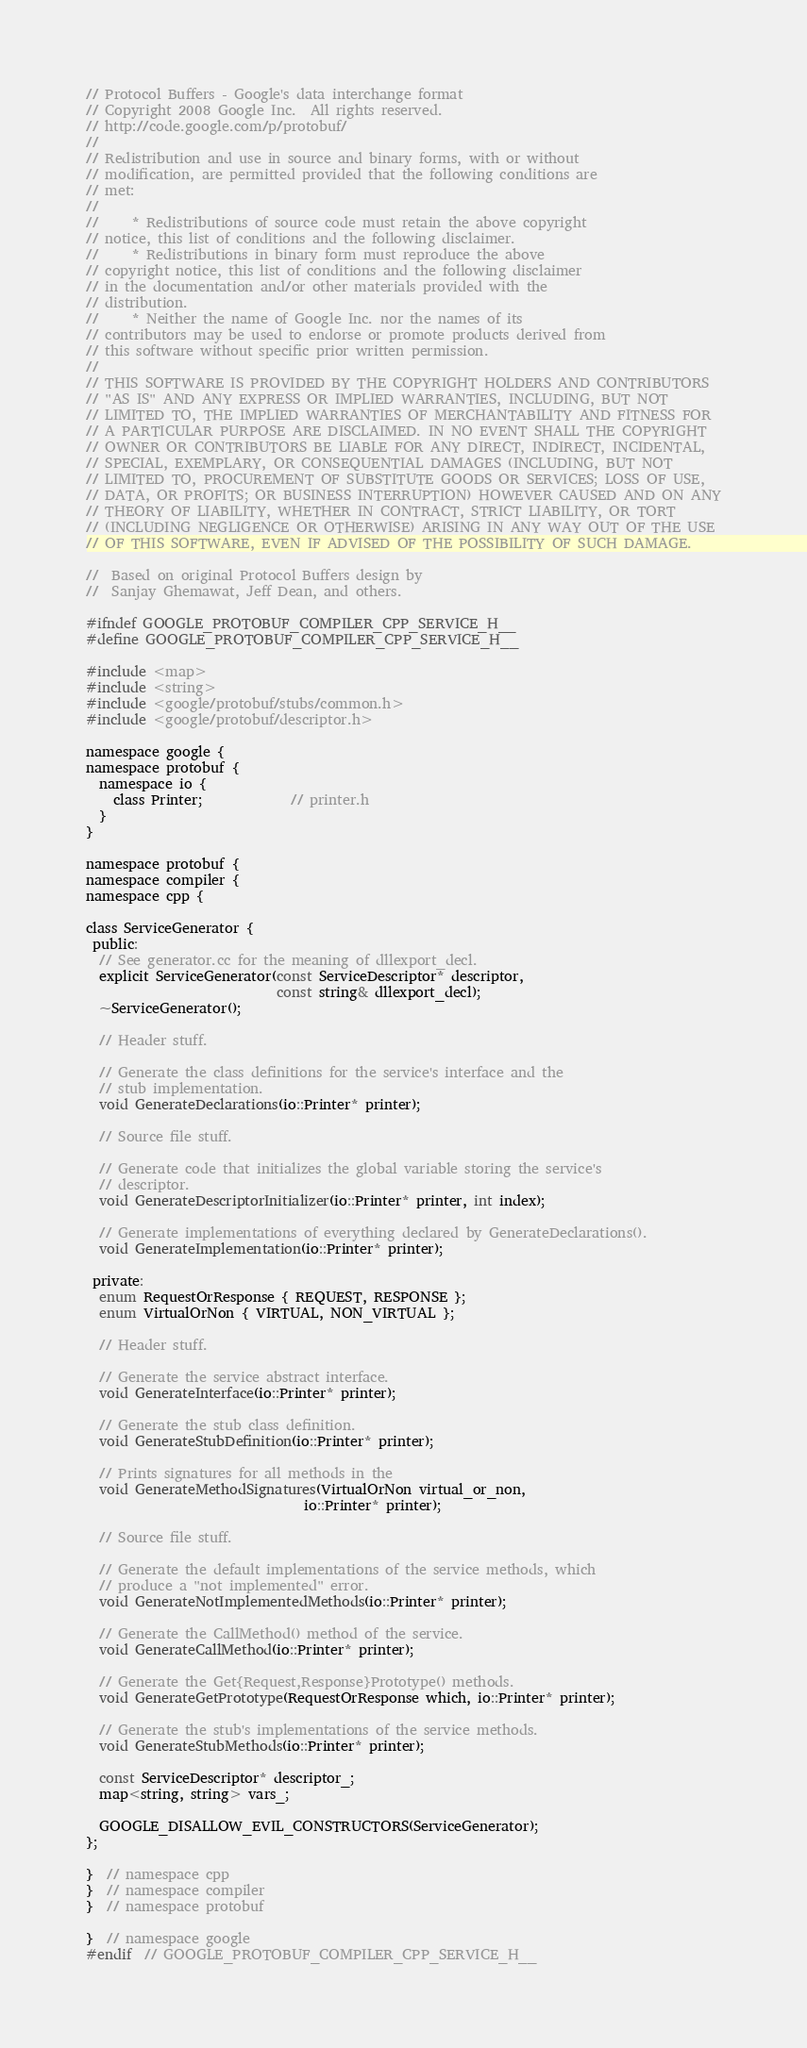<code> <loc_0><loc_0><loc_500><loc_500><_C_>// Protocol Buffers - Google's data interchange format
// Copyright 2008 Google Inc.  All rights reserved.
// http://code.google.com/p/protobuf/
//
// Redistribution and use in source and binary forms, with or without
// modification, are permitted provided that the following conditions are
// met:
//
//     * Redistributions of source code must retain the above copyright
// notice, this list of conditions and the following disclaimer.
//     * Redistributions in binary form must reproduce the above
// copyright notice, this list of conditions and the following disclaimer
// in the documentation and/or other materials provided with the
// distribution.
//     * Neither the name of Google Inc. nor the names of its
// contributors may be used to endorse or promote products derived from
// this software without specific prior written permission.
//
// THIS SOFTWARE IS PROVIDED BY THE COPYRIGHT HOLDERS AND CONTRIBUTORS
// "AS IS" AND ANY EXPRESS OR IMPLIED WARRANTIES, INCLUDING, BUT NOT
// LIMITED TO, THE IMPLIED WARRANTIES OF MERCHANTABILITY AND FITNESS FOR
// A PARTICULAR PURPOSE ARE DISCLAIMED. IN NO EVENT SHALL THE COPYRIGHT
// OWNER OR CONTRIBUTORS BE LIABLE FOR ANY DIRECT, INDIRECT, INCIDENTAL,
// SPECIAL, EXEMPLARY, OR CONSEQUENTIAL DAMAGES (INCLUDING, BUT NOT
// LIMITED TO, PROCUREMENT OF SUBSTITUTE GOODS OR SERVICES; LOSS OF USE,
// DATA, OR PROFITS; OR BUSINESS INTERRUPTION) HOWEVER CAUSED AND ON ANY
// THEORY OF LIABILITY, WHETHER IN CONTRACT, STRICT LIABILITY, OR TORT
// (INCLUDING NEGLIGENCE OR OTHERWISE) ARISING IN ANY WAY OUT OF THE USE
// OF THIS SOFTWARE, EVEN IF ADVISED OF THE POSSIBILITY OF SUCH DAMAGE.

//  Based on original Protocol Buffers design by
//  Sanjay Ghemawat, Jeff Dean, and others.

#ifndef GOOGLE_PROTOBUF_COMPILER_CPP_SERVICE_H__
#define GOOGLE_PROTOBUF_COMPILER_CPP_SERVICE_H__

#include <map>
#include <string>
#include <google/protobuf/stubs/common.h>
#include <google/protobuf/descriptor.h>

namespace google {
namespace protobuf {
  namespace io {
    class Printer;             // printer.h
  }
}

namespace protobuf {
namespace compiler {
namespace cpp {

class ServiceGenerator {
 public:
  // See generator.cc for the meaning of dllexport_decl.
  explicit ServiceGenerator(const ServiceDescriptor* descriptor,
                            const string& dllexport_decl);
  ~ServiceGenerator();

  // Header stuff.

  // Generate the class definitions for the service's interface and the
  // stub implementation.
  void GenerateDeclarations(io::Printer* printer);

  // Source file stuff.

  // Generate code that initializes the global variable storing the service's
  // descriptor.
  void GenerateDescriptorInitializer(io::Printer* printer, int index);

  // Generate implementations of everything declared by GenerateDeclarations().
  void GenerateImplementation(io::Printer* printer);

 private:
  enum RequestOrResponse { REQUEST, RESPONSE };
  enum VirtualOrNon { VIRTUAL, NON_VIRTUAL };

  // Header stuff.

  // Generate the service abstract interface.
  void GenerateInterface(io::Printer* printer);

  // Generate the stub class definition.
  void GenerateStubDefinition(io::Printer* printer);

  // Prints signatures for all methods in the
  void GenerateMethodSignatures(VirtualOrNon virtual_or_non,
                                io::Printer* printer);

  // Source file stuff.

  // Generate the default implementations of the service methods, which
  // produce a "not implemented" error.
  void GenerateNotImplementedMethods(io::Printer* printer);

  // Generate the CallMethod() method of the service.
  void GenerateCallMethod(io::Printer* printer);

  // Generate the Get{Request,Response}Prototype() methods.
  void GenerateGetPrototype(RequestOrResponse which, io::Printer* printer);

  // Generate the stub's implementations of the service methods.
  void GenerateStubMethods(io::Printer* printer);

  const ServiceDescriptor* descriptor_;
  map<string, string> vars_;

  GOOGLE_DISALLOW_EVIL_CONSTRUCTORS(ServiceGenerator);
};

}  // namespace cpp
}  // namespace compiler
}  // namespace protobuf

}  // namespace google
#endif  // GOOGLE_PROTOBUF_COMPILER_CPP_SERVICE_H__
</code> 